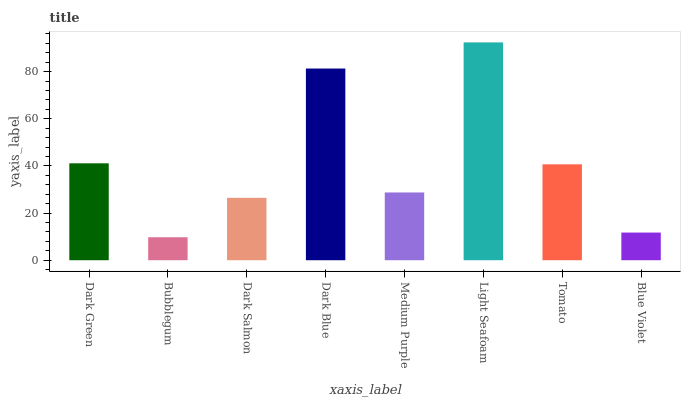Is Bubblegum the minimum?
Answer yes or no. Yes. Is Light Seafoam the maximum?
Answer yes or no. Yes. Is Dark Salmon the minimum?
Answer yes or no. No. Is Dark Salmon the maximum?
Answer yes or no. No. Is Dark Salmon greater than Bubblegum?
Answer yes or no. Yes. Is Bubblegum less than Dark Salmon?
Answer yes or no. Yes. Is Bubblegum greater than Dark Salmon?
Answer yes or no. No. Is Dark Salmon less than Bubblegum?
Answer yes or no. No. Is Tomato the high median?
Answer yes or no. Yes. Is Medium Purple the low median?
Answer yes or no. Yes. Is Dark Green the high median?
Answer yes or no. No. Is Bubblegum the low median?
Answer yes or no. No. 